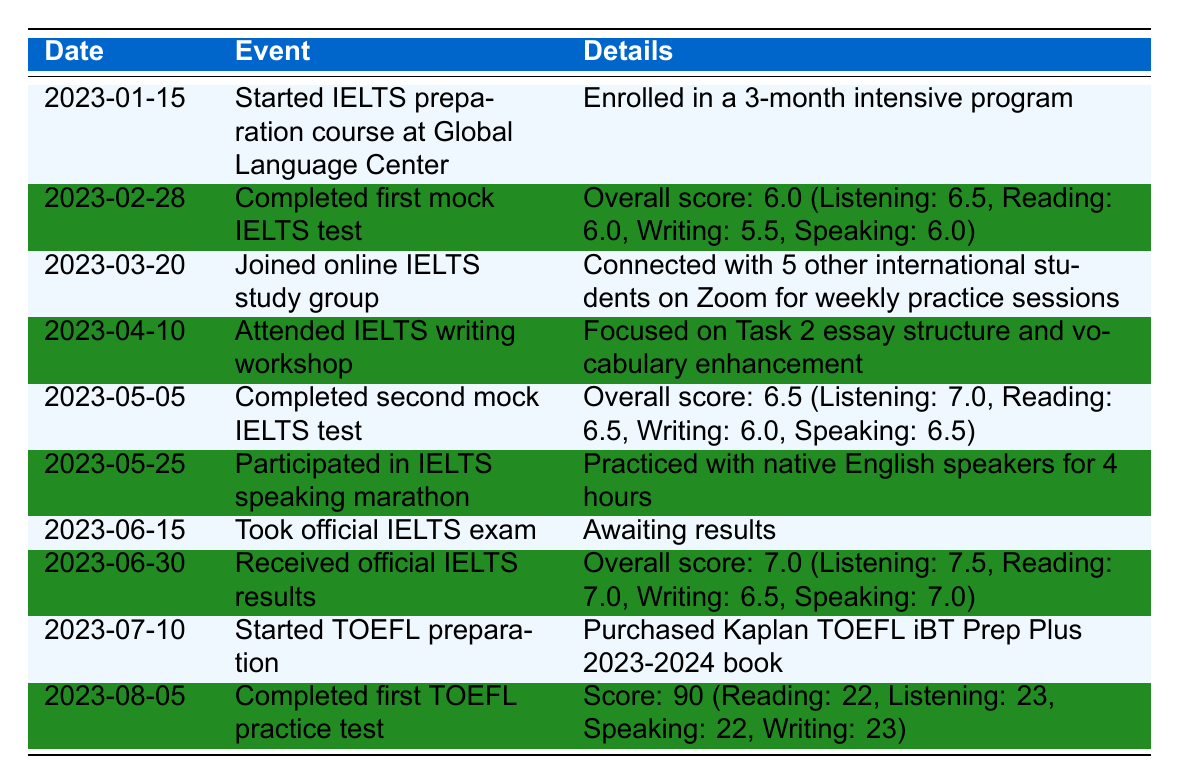What event took place on March 20, 2023? The table indicates that on March 20, 2023, the event was "Joined online IELTS study group." This is stated clearly in the corresponding row.
Answer: Joined online IELTS study group What was the overall score on the first mock IELTS test? According to the table, the overall score on the first mock IELTS test completed on February 28, 2023, was 6.0. This score is explicitly mentioned in the details.
Answer: 6.0 How many practice tests were completed before taking the official IELTS exam? The table shows that two mock IELTS tests were completed (February 28 and May 5) before the official IELTS exam taken on June 15. This is calculated by counting the mock tests listed.
Answer: 2 Is it true that the overall score improved between the first and second mock IELTS tests? Yes, it is true. The first mock test had an overall score of 6.0 and the second mock test had an overall score of 6.5. Since 6.5 is greater than 6.0, this demonstrates an improvement.
Answer: Yes What was the difference in Listening scores between the second mock IELTS test and the official IELTS results? The second mock IELTS test had a Listening score of 7.0, while the official IELTS results showed a Listening score of 7.5. The difference is calculated by subtracting 7.0 from 7.5, which equals 0.5.
Answer: 0.5 How many total events are listed in the table? The table has a total of 10 events listed, corresponding to different dates and descriptions provided. This can be counted directly from the number of rows in the timeline.
Answer: 10 What percentage of the events are directly related to IELTS preparation? There are 8 IELTS-related events (from the start of the IELTS course to the official exam results). Since there are 10 total events in the table, the percentage is (8/10) * 100 = 80%.
Answer: 80% On which date was the first TOEFL practice test completed? The first TOEFL practice test was completed on August 5, 2023, as indicated in the last row of the timeline.
Answer: August 5, 2023 What is the average score across all sections in the first TOEFL practice test? In the first TOEFL practice test, the scores were Reading: 22, Listening: 23, Speaking: 22, and Writing: 23. The average is calculated by adding these scores (22 + 23 + 22 + 23 = 90) and dividing by 4, resulting in an average of 22.5.
Answer: 22.5 